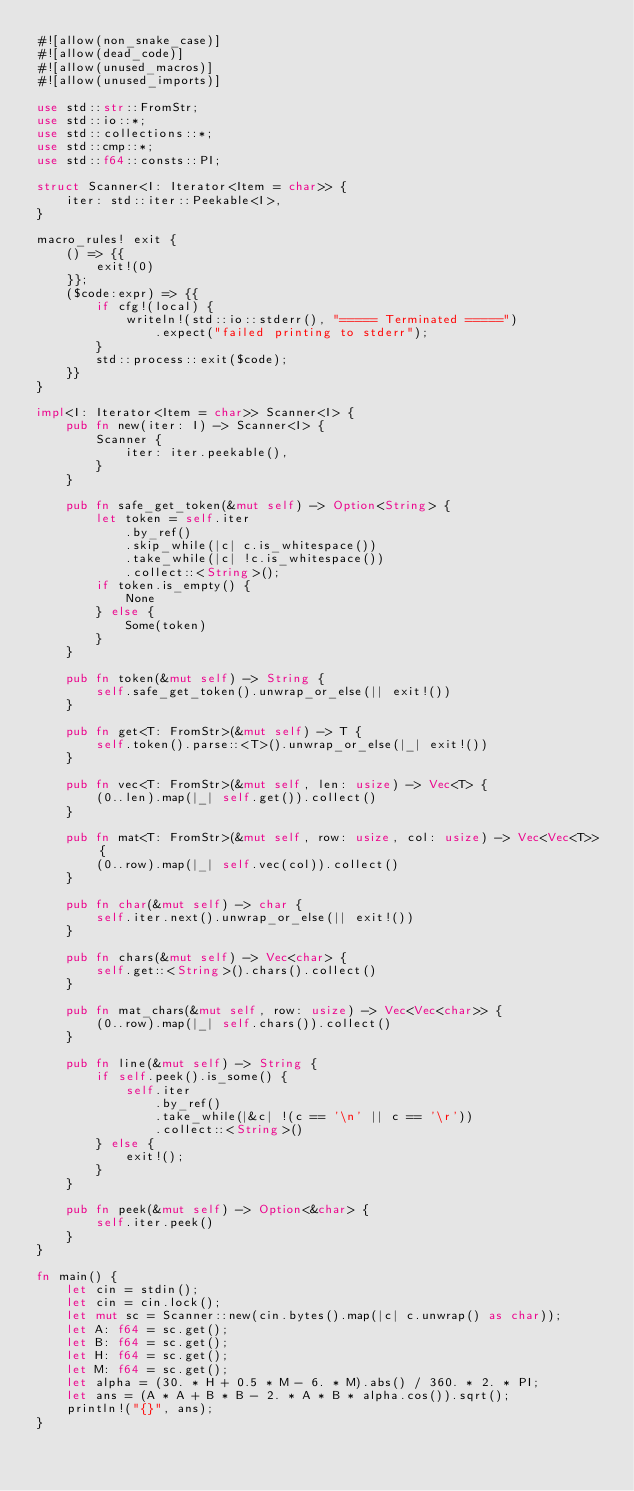Convert code to text. <code><loc_0><loc_0><loc_500><loc_500><_Rust_>#![allow(non_snake_case)]
#![allow(dead_code)]
#![allow(unused_macros)]
#![allow(unused_imports)]

use std::str::FromStr;
use std::io::*;
use std::collections::*;
use std::cmp::*;
use std::f64::consts::PI;

struct Scanner<I: Iterator<Item = char>> {
    iter: std::iter::Peekable<I>,
}

macro_rules! exit {
    () => {{
        exit!(0)
    }};
    ($code:expr) => {{
        if cfg!(local) {
            writeln!(std::io::stderr(), "===== Terminated =====")
                .expect("failed printing to stderr");
        }
        std::process::exit($code);
    }}
}

impl<I: Iterator<Item = char>> Scanner<I> {
    pub fn new(iter: I) -> Scanner<I> {
        Scanner {
            iter: iter.peekable(),
        }
    }

    pub fn safe_get_token(&mut self) -> Option<String> {
        let token = self.iter
            .by_ref()
            .skip_while(|c| c.is_whitespace())
            .take_while(|c| !c.is_whitespace())
            .collect::<String>();
        if token.is_empty() {
            None
        } else {
            Some(token)
        }
    }

    pub fn token(&mut self) -> String {
        self.safe_get_token().unwrap_or_else(|| exit!())
    }

    pub fn get<T: FromStr>(&mut self) -> T {
        self.token().parse::<T>().unwrap_or_else(|_| exit!())
    }

    pub fn vec<T: FromStr>(&mut self, len: usize) -> Vec<T> {
        (0..len).map(|_| self.get()).collect()
    }

    pub fn mat<T: FromStr>(&mut self, row: usize, col: usize) -> Vec<Vec<T>> {
        (0..row).map(|_| self.vec(col)).collect()
    }

    pub fn char(&mut self) -> char {
        self.iter.next().unwrap_or_else(|| exit!())
    }

    pub fn chars(&mut self) -> Vec<char> {
        self.get::<String>().chars().collect()
    }

    pub fn mat_chars(&mut self, row: usize) -> Vec<Vec<char>> {
        (0..row).map(|_| self.chars()).collect()
    }

    pub fn line(&mut self) -> String {
        if self.peek().is_some() {
            self.iter
                .by_ref()
                .take_while(|&c| !(c == '\n' || c == '\r'))
                .collect::<String>()
        } else {
            exit!();
        }
    }

    pub fn peek(&mut self) -> Option<&char> {
        self.iter.peek()
    }
}

fn main() {
    let cin = stdin();
    let cin = cin.lock();
    let mut sc = Scanner::new(cin.bytes().map(|c| c.unwrap() as char));
    let A: f64 = sc.get();
    let B: f64 = sc.get();
    let H: f64 = sc.get();
    let M: f64 = sc.get();
    let alpha = (30. * H + 0.5 * M - 6. * M).abs() / 360. * 2. * PI;
    let ans = (A * A + B * B - 2. * A * B * alpha.cos()).sqrt();
    println!("{}", ans);
}
</code> 